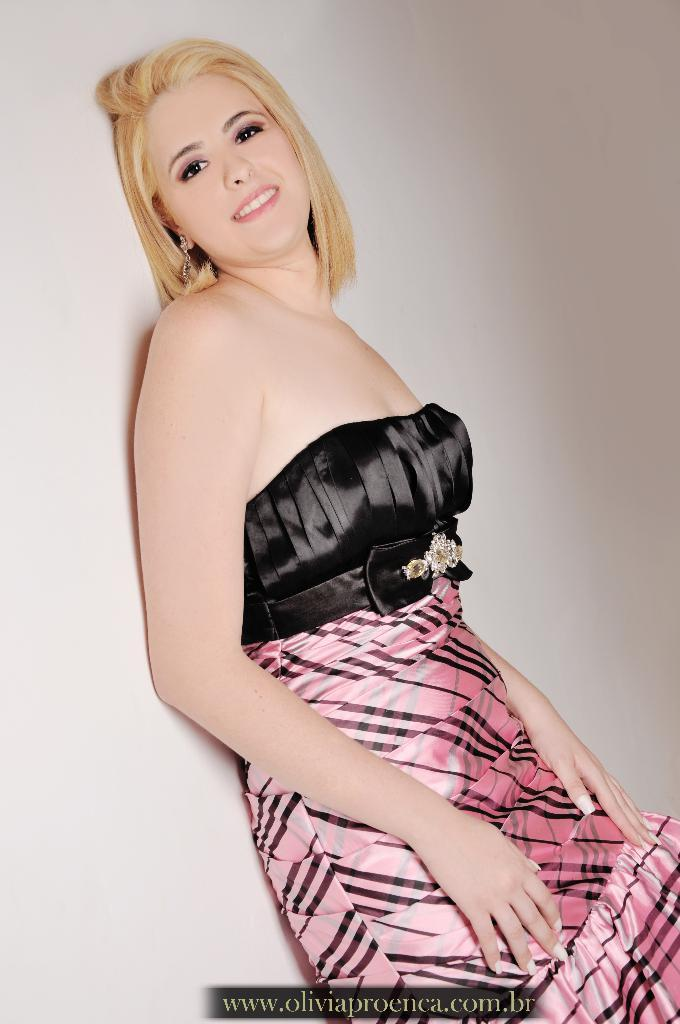Who is present in the image? There is a woman in the image. What is the woman wearing? The woman is wearing a dress with a black and pink color combination. What is the background of the image? The woman is leaning on a white color wall. Is there any text or marking on the image? Yes, there is a watermark at the bottom of the image. How many cows are in the image? There are no cows present in the image. What type of flock is visible in the image? There is no flock visible in the image. 